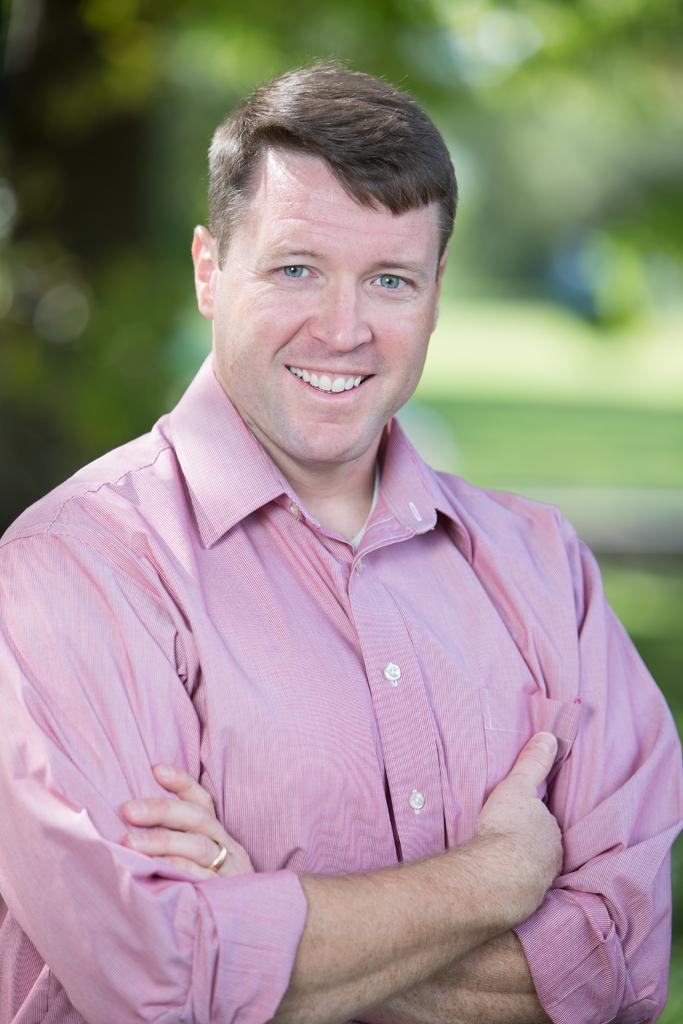What is the main subject of the image? The main subject of the image is a man. What is the man doing in the image? The man is folding his hands and smiling. Can you describe the background of the image? The background of the image is blurry. What type of surprise can be seen in the man's hands in the image? There is no surprise visible in the man's hands in the image; he is simply folding them. 